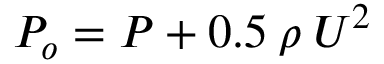Convert formula to latex. <formula><loc_0><loc_0><loc_500><loc_500>P _ { o } = P + 0 . 5 \, \rho \, U ^ { 2 }</formula> 